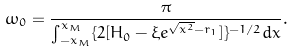Convert formula to latex. <formula><loc_0><loc_0><loc_500><loc_500>\omega _ { 0 } = \frac { \pi } { \int _ { - x _ { M } } ^ { x _ { M } } \{ 2 [ H _ { 0 } - \xi e ^ { \sqrt { x ^ { 2 } } - r _ { 1 } } ] \} ^ { - 1 / 2 } d x } .</formula> 